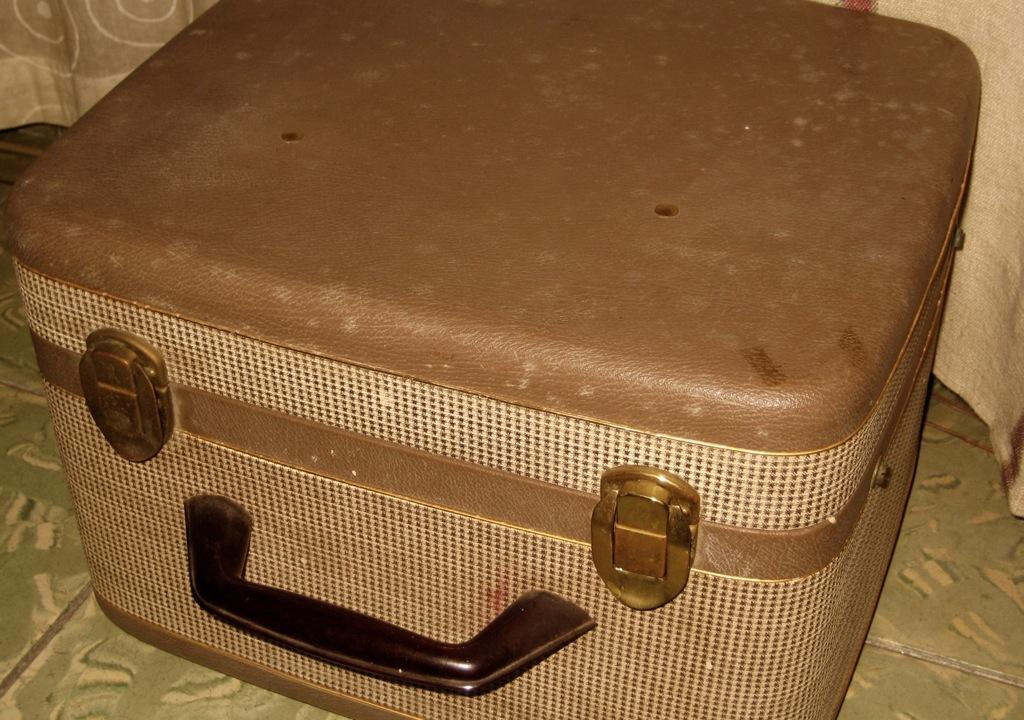What object can be seen in the image? There is a suitcase in the image. Can you tell me what type of thrill the stranger is experiencing while holding the locket in the image? There is no stranger or locket present in the image; it only features a suitcase. 